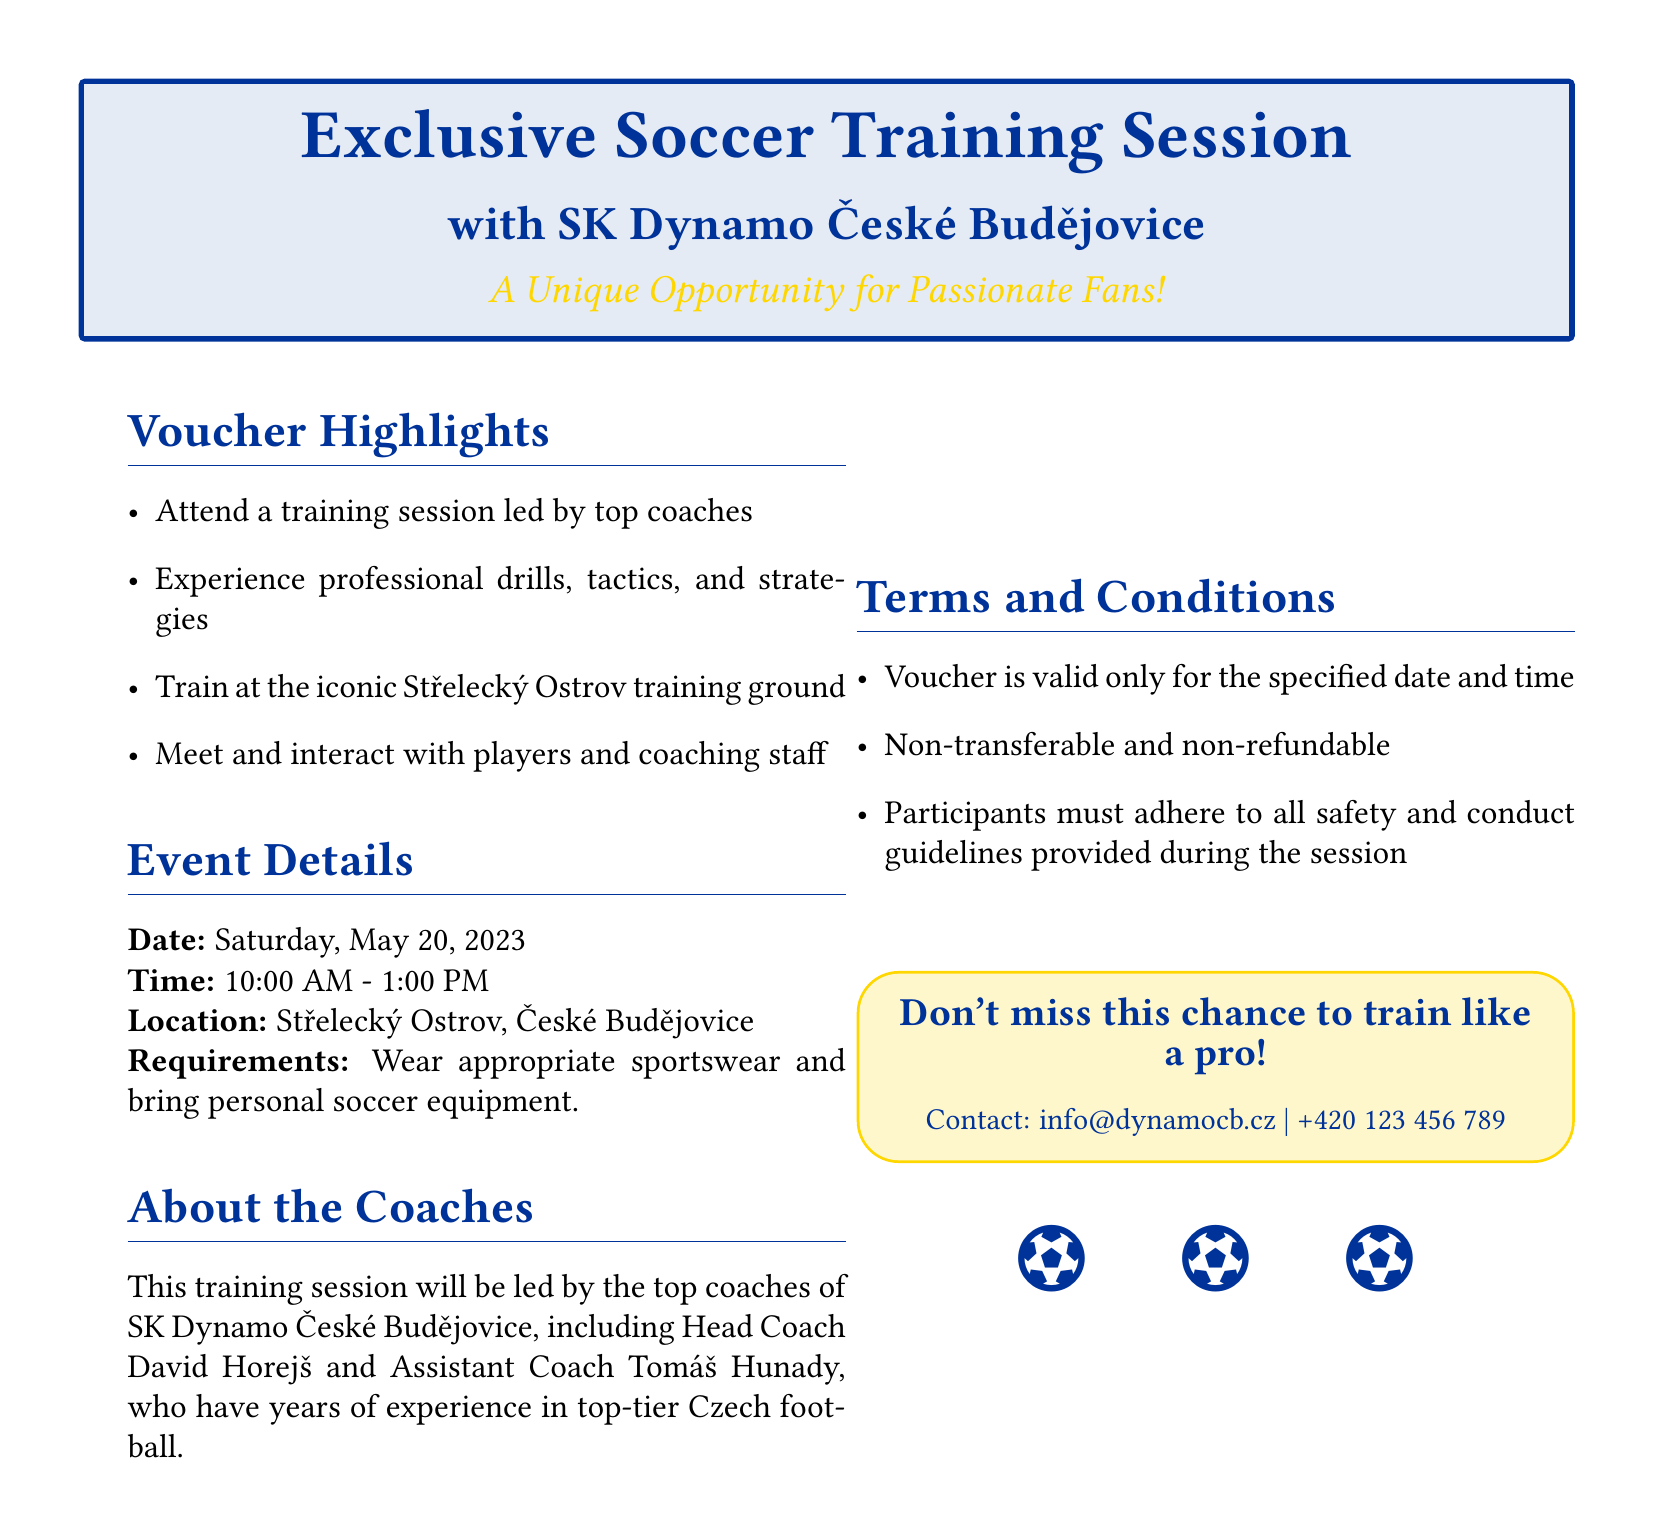What is the date of the training session? The date is specified in the document under "Event Details" as Saturday, May 20, 2023.
Answer: Saturday, May 20, 2023 Who leads the training session? The document mentions that the training session will be led by top coaches, specifically Head Coach David Horejš and Assistant Coach Tomáš Hunady.
Answer: David Horejš Where will the training session take place? The location is mentioned under "Event Details" as Střelecký Ostrov, České Budějovice.
Answer: Střelecký Ostrov, České Budějovice What should participants wear? The voucher states that participants must wear appropriate sportswear.
Answer: Appropriate sportswear Is the voucher transferable? The terms and conditions provide that the voucher is non-transferable.
Answer: Non-transferable What time does the training session start? The start time is specified under "Event Details" in the document as 10:00 AM.
Answer: 10:00 AM How long is the training session scheduled to last? The time range mentioned in the document is from 10:00 AM to 1:00 PM, indicating a duration of 3 hours.
Answer: 3 hours What is the contact email provided in the document? The contact information at the end of the document lists the email as info@dynamocb.cz.
Answer: info@dynamocb.cz 